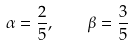<formula> <loc_0><loc_0><loc_500><loc_500>\alpha = \frac { 2 } { 5 } , \quad \beta = \frac { 3 } { 5 }</formula> 